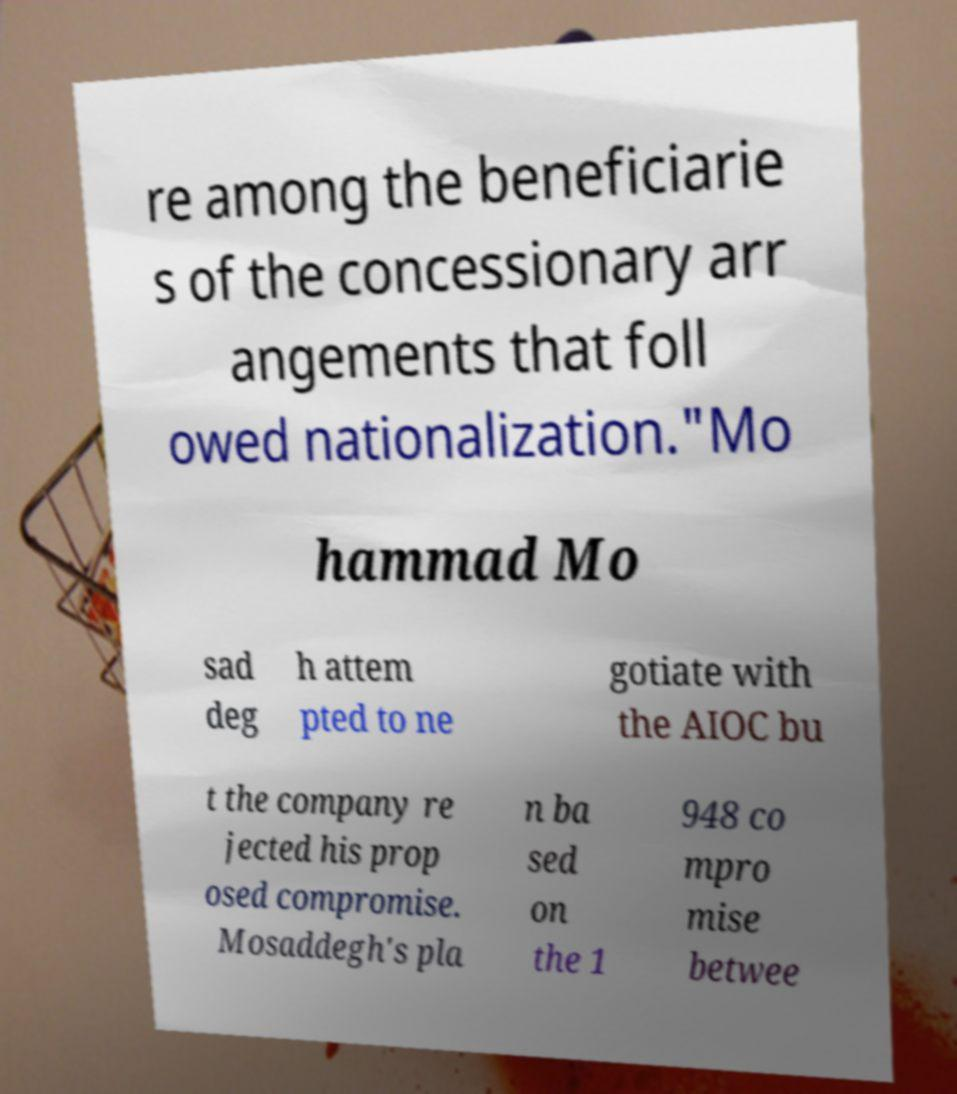There's text embedded in this image that I need extracted. Can you transcribe it verbatim? re among the beneficiarie s of the concessionary arr angements that foll owed nationalization."Mo hammad Mo sad deg h attem pted to ne gotiate with the AIOC bu t the company re jected his prop osed compromise. Mosaddegh's pla n ba sed on the 1 948 co mpro mise betwee 